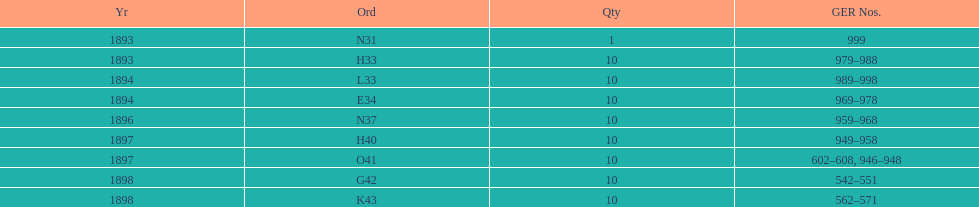What is the number of years with a quantity of 10? 5. 